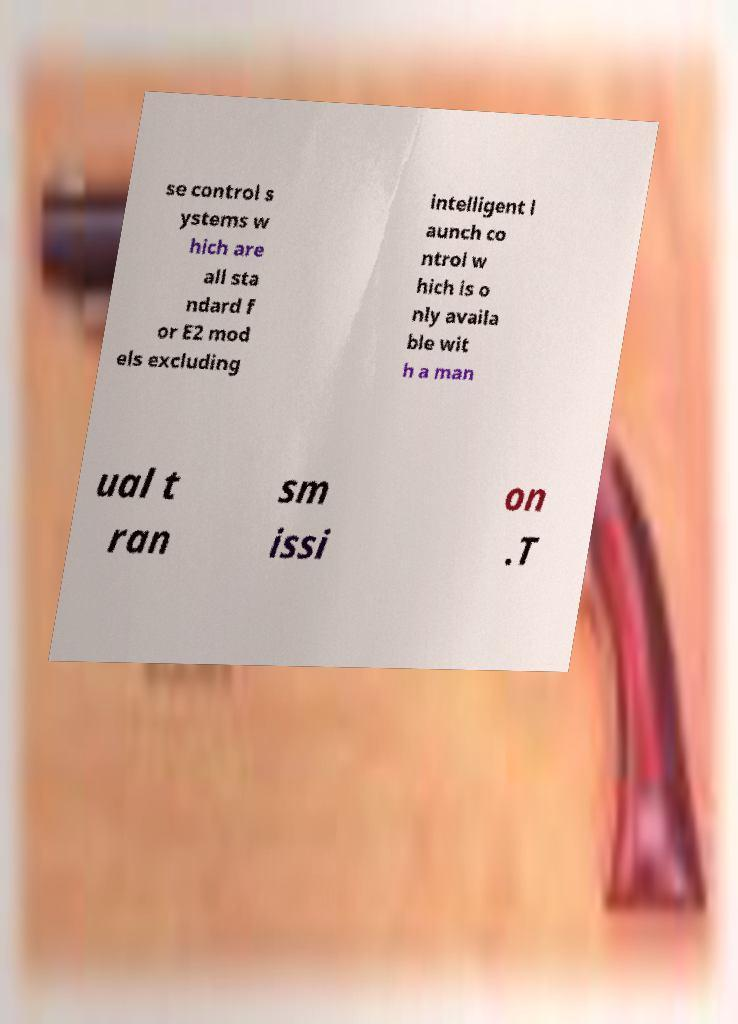I need the written content from this picture converted into text. Can you do that? se control s ystems w hich are all sta ndard f or E2 mod els excluding intelligent l aunch co ntrol w hich is o nly availa ble wit h a man ual t ran sm issi on .T 